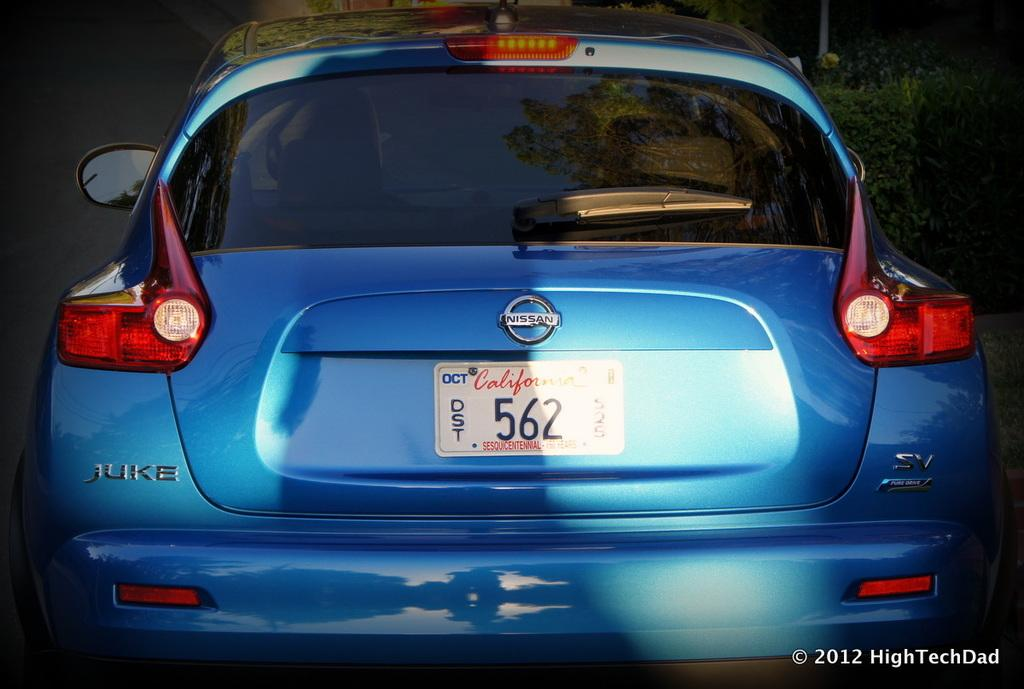<image>
Present a compact description of the photo's key features. The blue Nissan Juke is from the state of California 